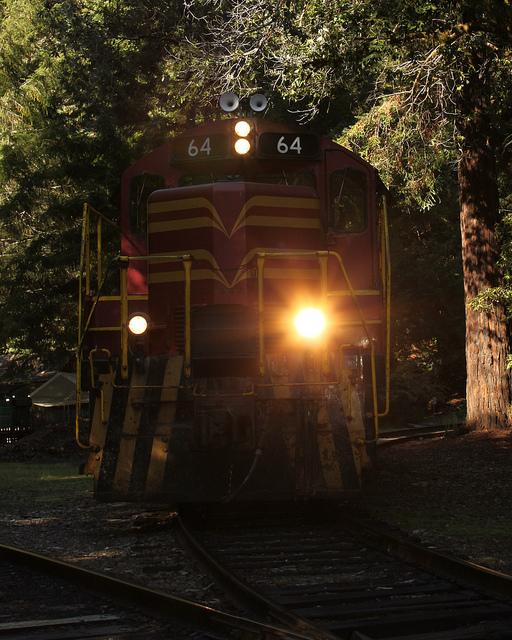Is this the front or back of the train?
Write a very short answer. Front. What is the number on the train?
Write a very short answer. 64. Are the train's lights on?
Give a very brief answer. Yes. 